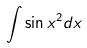<formula> <loc_0><loc_0><loc_500><loc_500>\int \sin x ^ { 2 } d x</formula> 